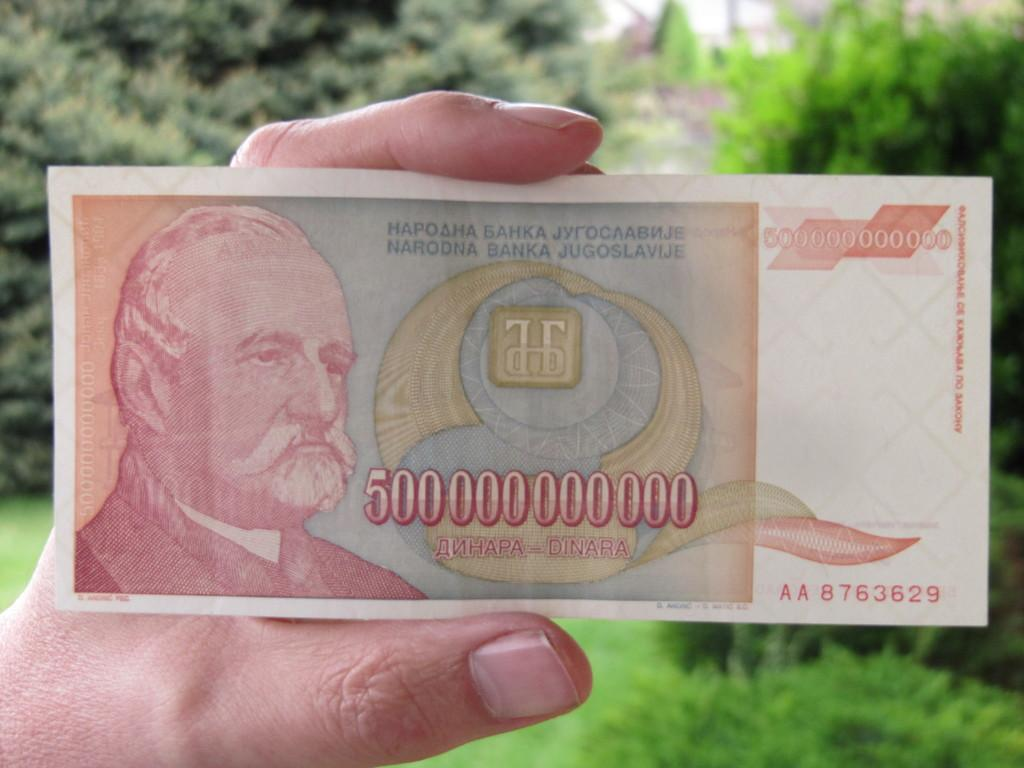What is being held by the hand in the image? There is a paper in the hand. What can be seen in the background of the image? There are trees visible behind the hand. How many zebras can be seen in the image? There are no zebras present in the image. What type of fan is being used in the image? There is no fan present in the image. 